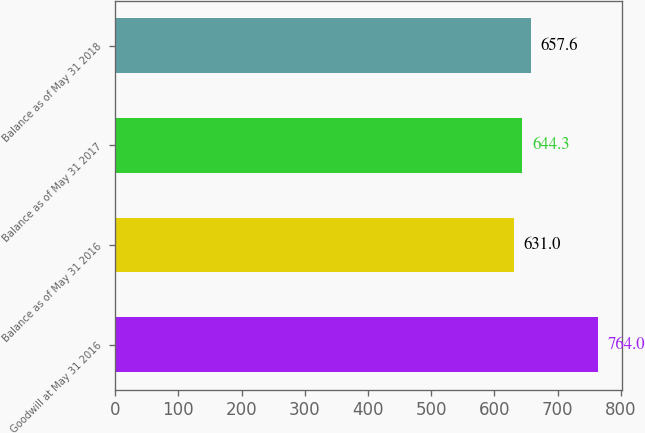Convert chart to OTSL. <chart><loc_0><loc_0><loc_500><loc_500><bar_chart><fcel>Goodwill at May 31 2016<fcel>Balance as of May 31 2016<fcel>Balance as of May 31 2017<fcel>Balance as of May 31 2018<nl><fcel>764<fcel>631<fcel>644.3<fcel>657.6<nl></chart> 